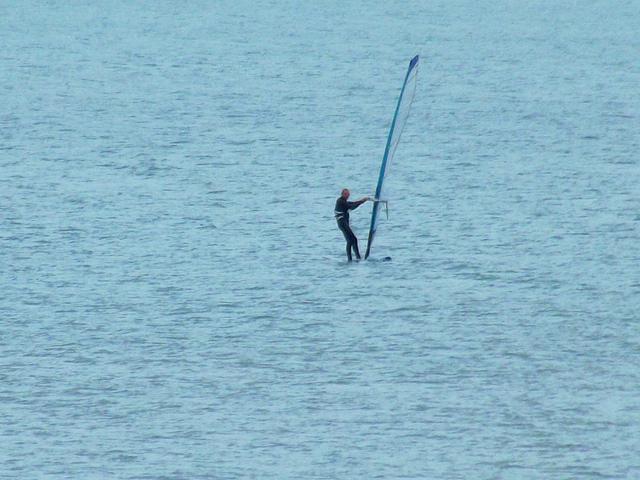How many food poles for the giraffes are there?
Give a very brief answer. 0. 